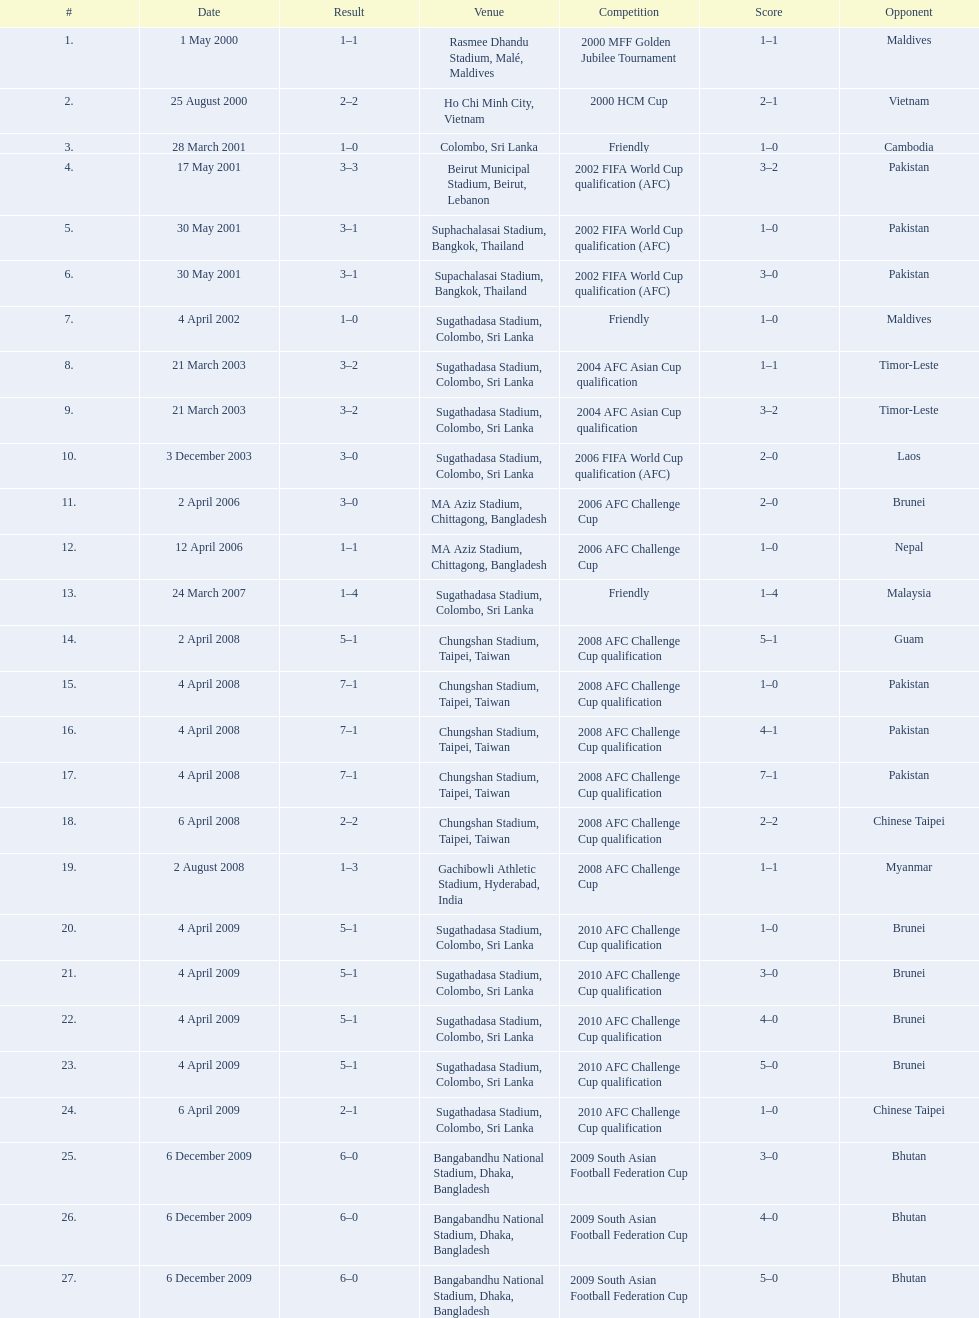What is the total count of games played against vietnam? 1. 